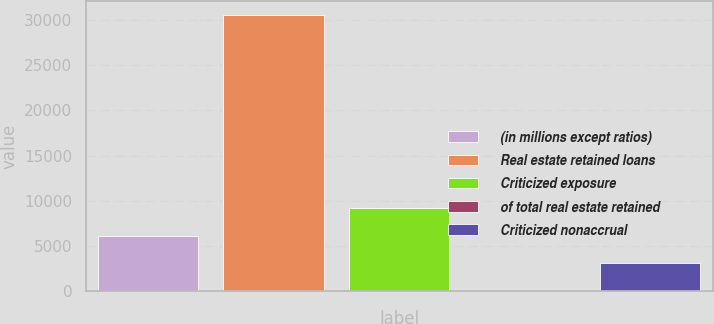<chart> <loc_0><loc_0><loc_500><loc_500><bar_chart><fcel>(in millions except ratios)<fcel>Real estate retained loans<fcel>Criticized exposure<fcel>of total real estate retained<fcel>Criticized nonaccrual<nl><fcel>6130.73<fcel>30604<fcel>9189.89<fcel>12.41<fcel>3071.57<nl></chart> 